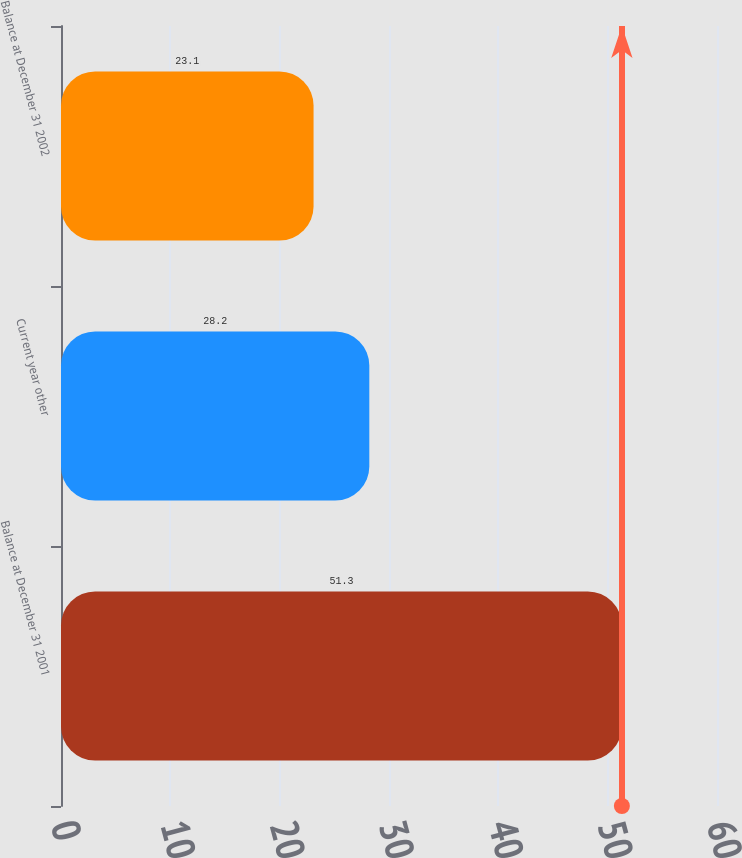<chart> <loc_0><loc_0><loc_500><loc_500><bar_chart><fcel>Balance at December 31 2001<fcel>Current year other<fcel>Balance at December 31 2002<nl><fcel>51.3<fcel>28.2<fcel>23.1<nl></chart> 